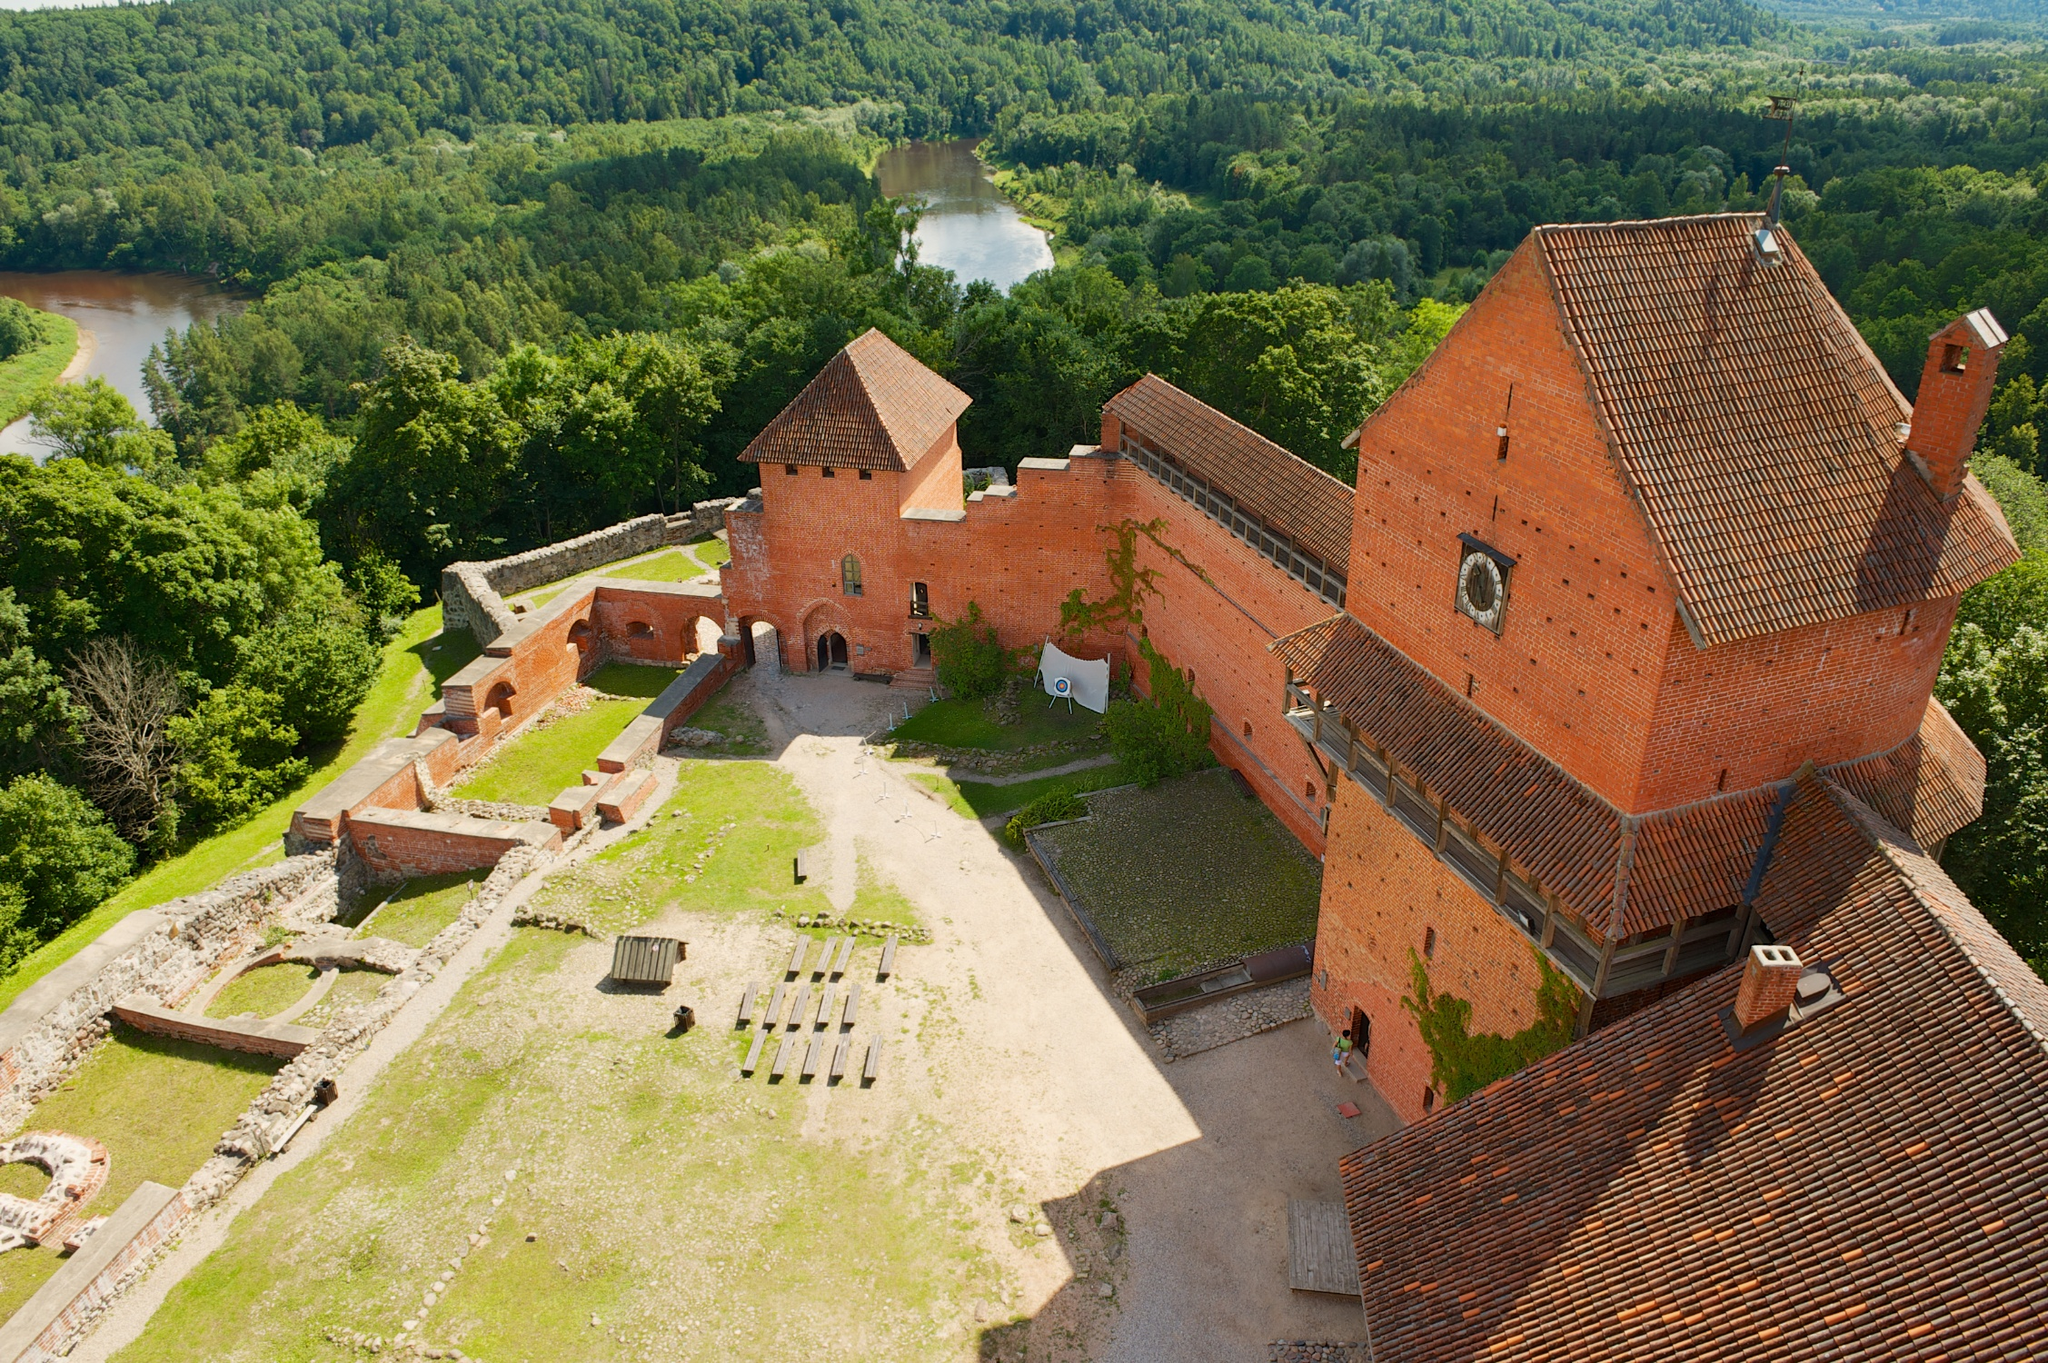Imagine if this castle had a secret portal. Where would it lead? Imagine if hidden deep within the walls of this castle lay a secret portal, obscured behind an ancient tapestry in the grand hall. This portal, crafted by an enigmatic sorcerer centuries ago, would transport those brave enough to traverse it to a whimsical, otherworldly realm. Stepping through, one would find themselves in an enchanted forest where trees glowed with an ethereal light and mythical creatures roamed. The air would be filled with the scent of exotic flowers, and waterfalls of pure crystalline water would cascade into serene pools. In the heart of this magical land lies the sparkling city of Eldoria, home to an ancient civilization that possesses wisdom and knowledge long forgotten by the mortal world. This portal offers not just an escape, but a passage to adventure, discovery, and the unfolding of grand quests that intertwine with the very fabric of existence. 